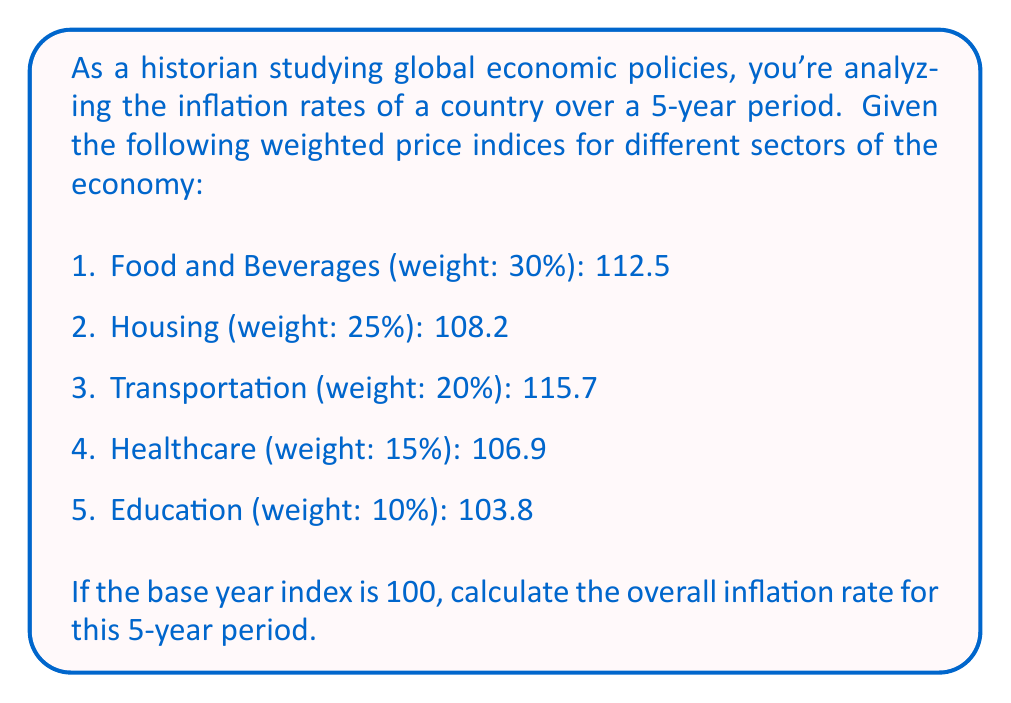Help me with this question. To solve this problem, we need to follow these steps:

1. Calculate the weighted average of the price indices:
   Let's denote the weights as $w_i$ and the price indices as $P_i$.
   The weighted average is given by:

   $$\text{Weighted Average} = \sum_{i=1}^n w_i P_i$$

   Calculating:
   $$\begin{align*}
   \text{Weighted Average} &= (0.30 \times 112.5) + (0.25 \times 108.2) + (0.20 \times 115.7) \\
   &\quad + (0.15 \times 106.9) + (0.10 \times 103.8) \\
   &= 33.75 + 27.05 + 23.14 + 16.035 + 10.38 \\
   &= 110.355
   \end{align*}$$

2. Calculate the inflation rate:
   The inflation rate is the percentage change in the price index from the base year to the current year.
   
   $$\text{Inflation Rate} = \frac{\text{Current Index} - \text{Base Index}}{\text{Base Index}} \times 100\%$$

   Substituting the values:
   $$\begin{align*}
   \text{Inflation Rate} &= \frac{110.355 - 100}{100} \times 100\% \\
   &= 0.10355 \times 100\% \\
   &= 10.355\%
   \end{align*}$$

Therefore, the overall inflation rate for this 5-year period is approximately 10.355%.
Answer: 10.355% 